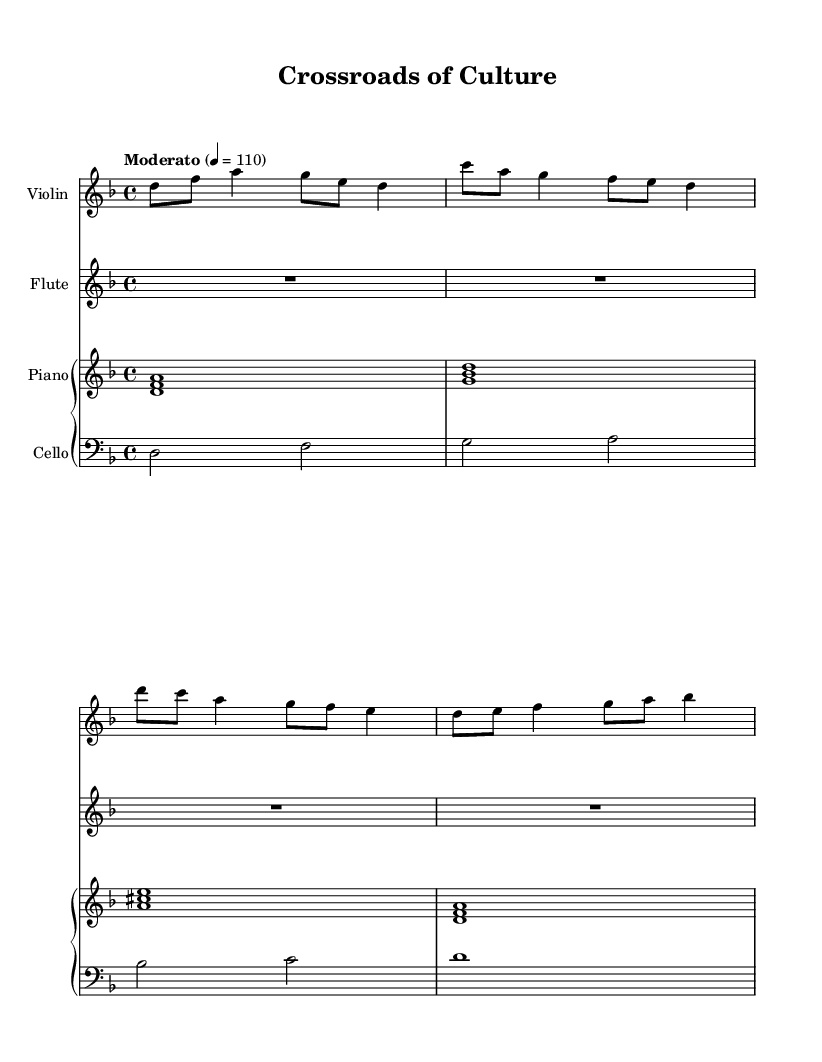What is the key signature of this music? The key signature of this music is indicated at the beginning of the staff. It shows one flat, which signifies that it is in the key of D minor.
Answer: D minor What is the time signature of the piece? The time signature appears at the beginning and is represented as a fraction. It is 4 over 4, meaning there are four beats in each measure and a quarter note receives one beat.
Answer: 4/4 What is the tempo marking of this music? The tempo marking is usually written at the beginning of the score, indicating the speed of the music. It states "Moderato" and a metronome mark of 110 beats per minute, suggesting a moderate pace.
Answer: Moderato How many instruments are used in this score? By identifying the separate staves in the score, we see that there are four distinct instruments indicated: violin, flute, piano, and cello.
Answer: Four Which instrument has the highest pitch range? The highest pitch is found in the violin part, as it typically plays in a higher octave than the other instruments. By examining the written notes, we can see that it includes note values that are among the highest in the score.
Answer: Violin What chord is played at the beginning of the piano part? The chord is formed by the combination of notes specified at the start of the piano part. The first notes indicated are D, F, and A played simultaneously, which confirms it is a D minor chord.
Answer: D minor How does the orchestration blend Eastern and Western styles? This question requires an understanding of the instrumentation and harmonic structures typically found in Eastern and Western music. The use of Western instruments like flute and piano alongside traditional scales and melodic patterns hints at a fusion of music styles. The composition's harmonic structure reflects Western practices while the melodic framing may hint at Eastern scales, suggesting a cross-cultural blend.
Answer: Fusion of styles 